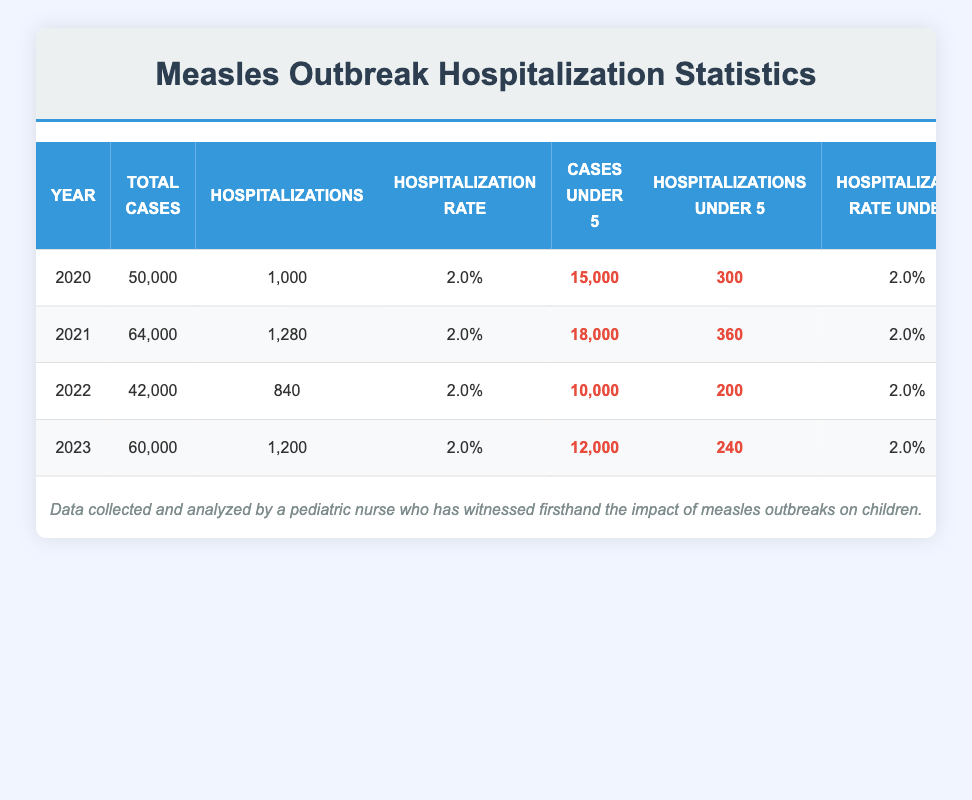What was the total number of measles cases in 2021? According to the table, the column for total cases in the year 2021 shows a value of 64,000.
Answer: 64,000 What is the hospitalization rate for children under 5 years old in 2022? The table has a specific column for hospitalization rate under 5 in 2022, which displays 2.0%.
Answer: 2.0% How many more hospitalizations were there for children under 5 in 2021 compared to 2022? For 2021, the hospitalizations under 5 were 360, and for 2022, it was 200. The difference is 360 - 200 = 160.
Answer: 160 Did the total cases in 2023 exceed those in 2020? The total cases in 2023 are 60,000 and in 2020 they are 50,000. Since 60,000 is greater than 50,000, the statement is true.
Answer: Yes What was the average hospitalization rate across all years for children under 5? The hospitalization rate under 5 is consistently 2.0% for all years: 2020, 2021, 2022, and 2023. To find the average, sum all the rates (2.0 + 2.0 + 2.0 + 2.0) = 8.0%, then divide by 4 (the number of years) giving us 8.0% / 4 = 2.0%.
Answer: 2.0% In which year did the hospitalizations for measles outbreaks for children under 5 reach the highest number? By examining the column for hospitalizations under 5, it is clear that 2021 had the highest value at 360.
Answer: 2021 How many total hospitalizations occurred in the four years combined? To find this, we need to sum the total hospitalizations for each year: 1,000 (2020) + 1,280 (2021) + 840 (2022) + 1,200 (2023) = 4,320.
Answer: 4,320 Was the hospitalization rate consistent across the four years? Observing the hospitalization rates for each year reveals that they are all recorded as 2.0%, demonstrating consistency throughout.
Answer: Yes What is the change in the number of children under 5 cases from 2021 to 2023? In 2021, the number of children under 5 cases was 18,000, and in 2023 it was 12,000. The change is 18,000 - 12,000 = 6,000 cases.
Answer: 6,000 